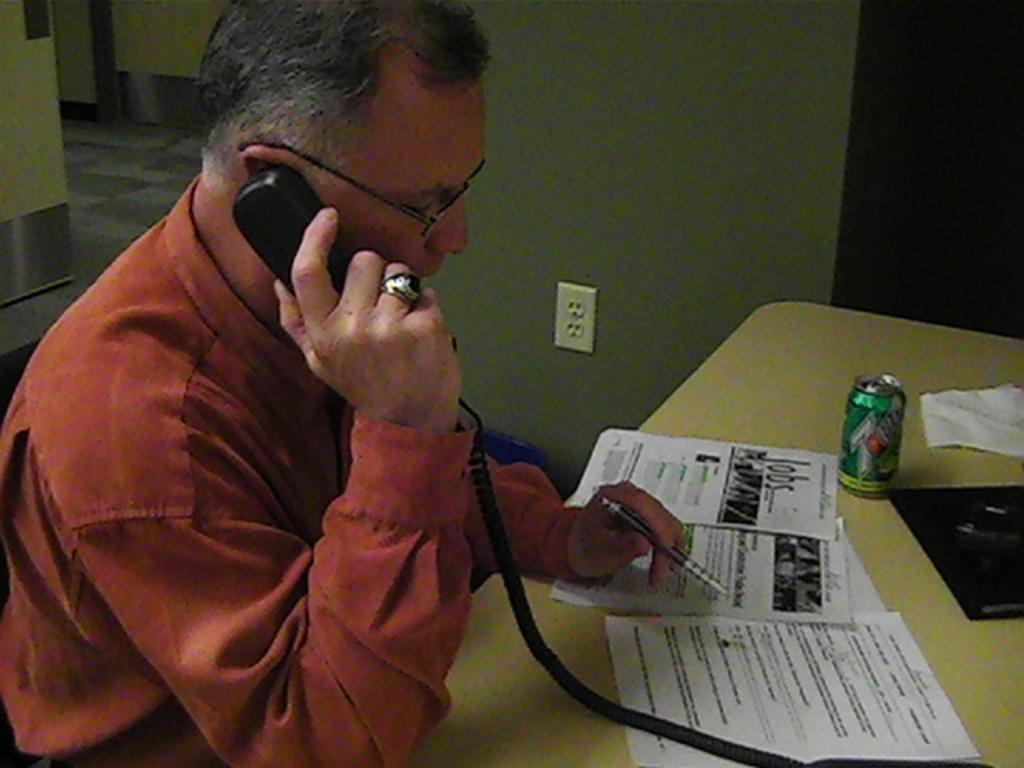How would you summarize this image in a sentence or two? In this image I can see a person wearing brown colored shirt is sitting and holding a telephone and a pen in his hands. In front of him I can see a desk on which I can see few papers, a black colored object and a tin. In the background I can see the wall, a switchboard and the floor. 